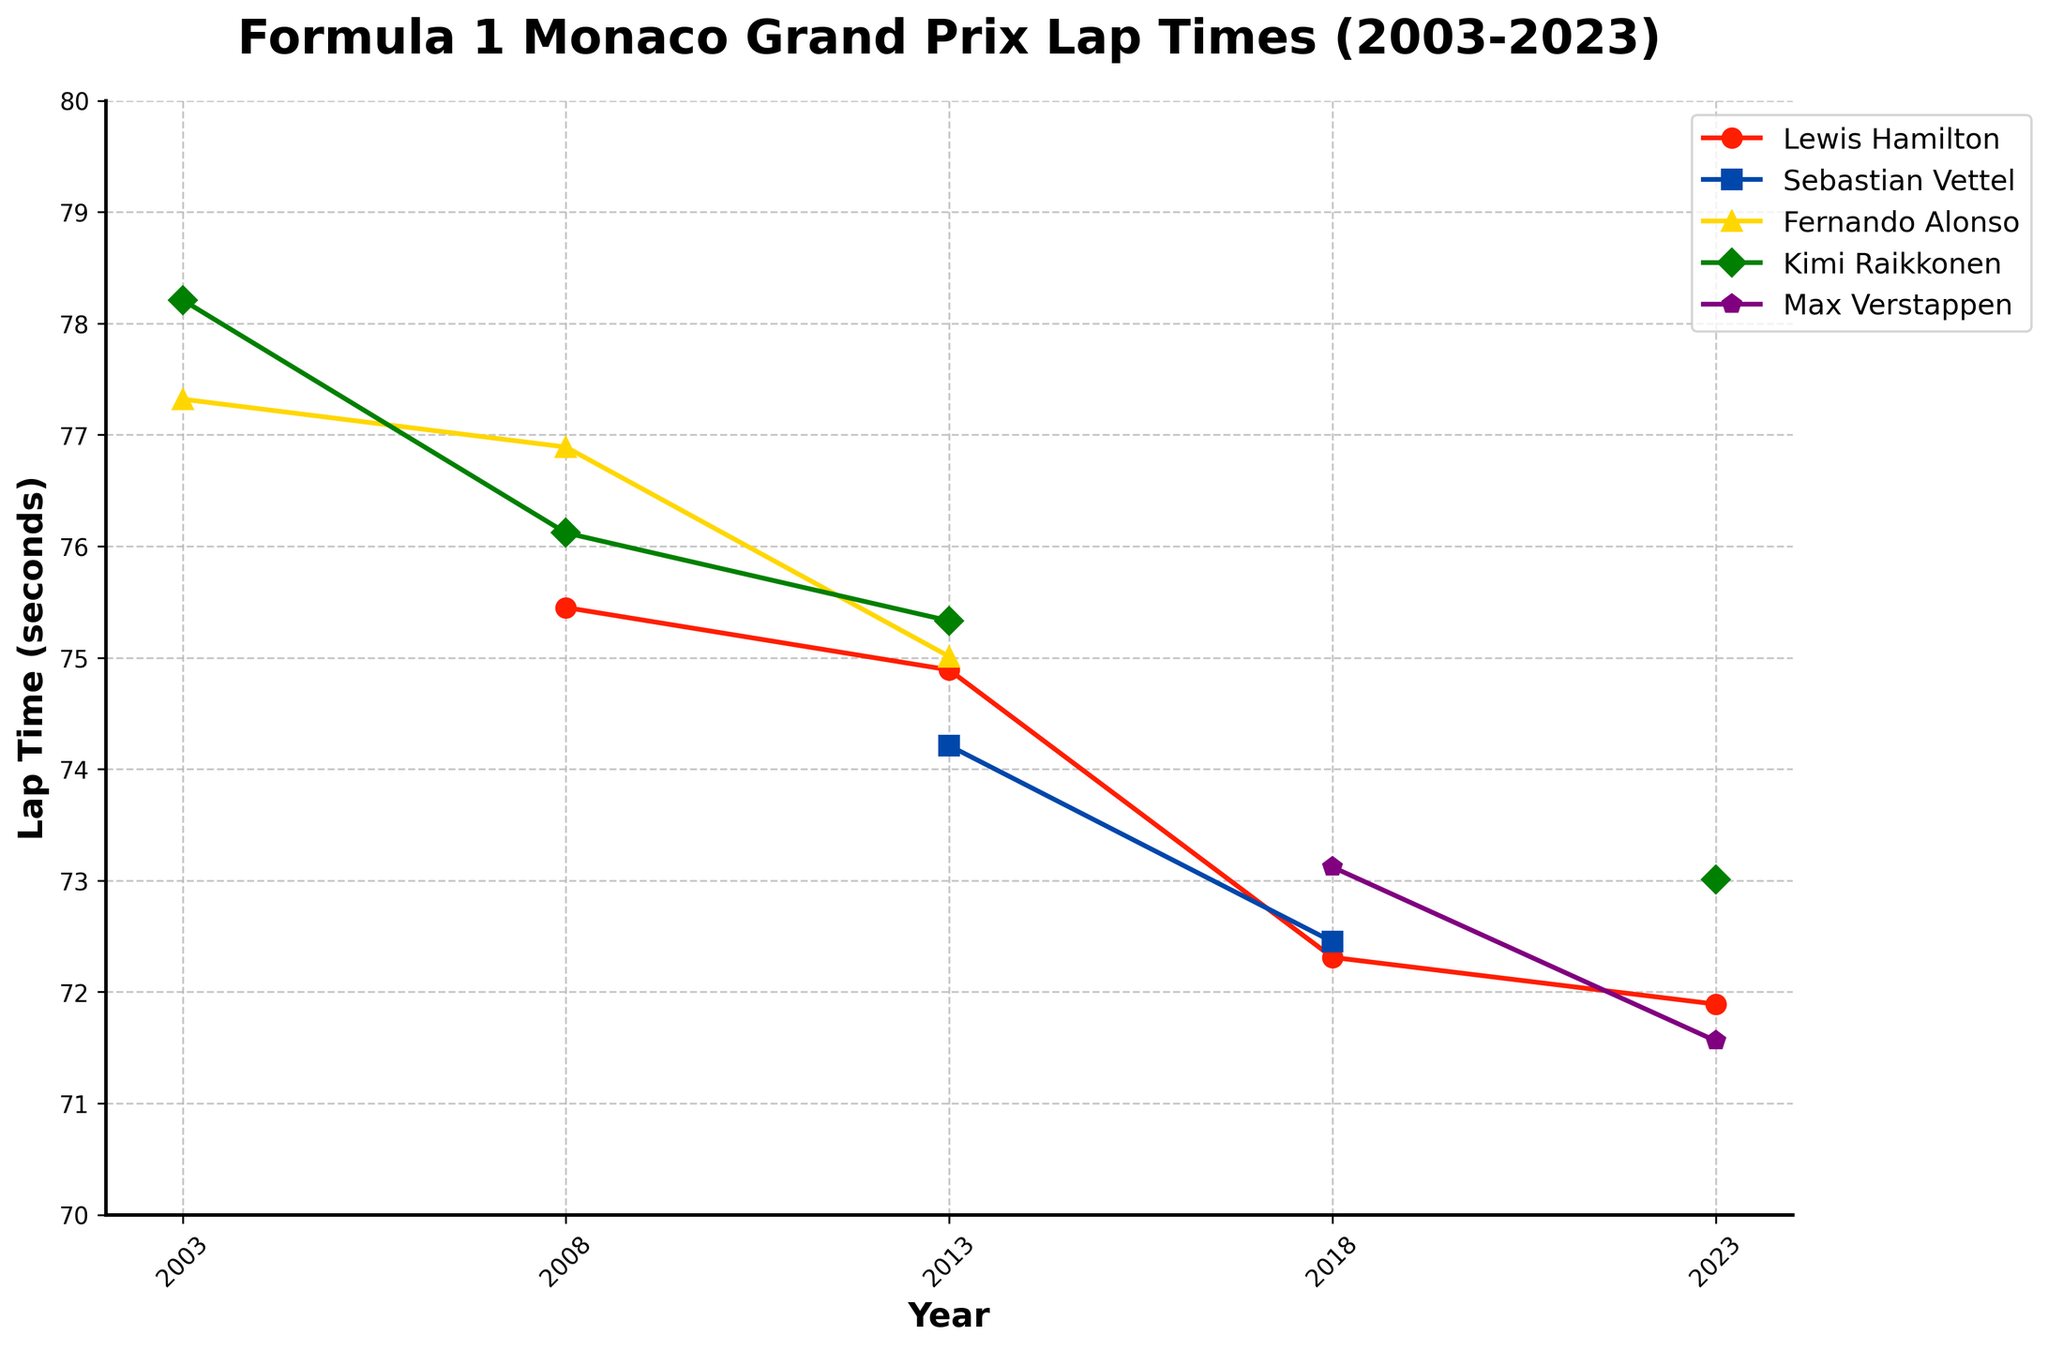Which driver had the fastest lap time in 2023? Look at the lap times for the year 2023. Max Verstappen has the lowest lap time of 71.56 seconds, which is less than Lewis Hamilton's 71.89 seconds and Kimi Raikkonen's 73.01 seconds.
Answer: Max Verstappen What is the title of the plot? The title is written at the top of the plot.
Answer: Formula 1 Monaco Grand Prix Lap Times (2003-2023) How many years have data points for more than three drivers? Count the number of years where more than three drivers have recorded lap times.
Answer: Three years (2008, 2013, 2023) What is Sebastian Vettel's fastest lap time, and in which year did it occur? Sebastian Vettel's lap times are only available for the year 2013 and 2018 in the plot. The fastest among these times is 74.21 seconds in 2013.
Answer: 74.21 seconds in 2013 Which driver showed an improvement in lap times from 2013 to 2018? Compare the lap times in 2013 and 2018 for drivers with data in both years. Sebastian Vettel had a lap time of 74.21 seconds in 2013 and 72.45 seconds in 2018.
Answer: Sebastian Vettel In which year did Lewis Hamilton have his slowest lap time? Look at the points where Lewis Hamilton's lap times are plotted across the years. The slowest time is 75.45 seconds in 2008.
Answer: 2008 Among the years 2003, 2008, and 2023, which year had the highest average lap time for the available drivers? Calculate the average lap time of the available drivers for each of these years. For 2003, there are two lap times: (77.32 + 78.21)/2 = 77.765. For 2008, there are three: (75.45 + 76.89 + 76.12)/3 = 76.1533. For 2023, there are three lap times: (71.89 + 73.01 + 71.56)/3 = 72.82. 2003 has the highest average.
Answer: 2003 Which driver's lap time data is missing for the most years? Count the years for which each driver's data is missing. Fernando Alonso and Kimi Raikkonen are both missing for three years.
Answer: Fernando Alonso, Kimi Raikkonen Between 2013 and 2023, did Max Verstappen's lap times increase or decrease? Compare the lap times of Max Verstappen in 2013 and 2023. In 2013, he had no data. In 2023, his lap time is 71.56 seconds. Since there is no previous data to compare from 2013, this question is invalid.
Answer: Not applicable 